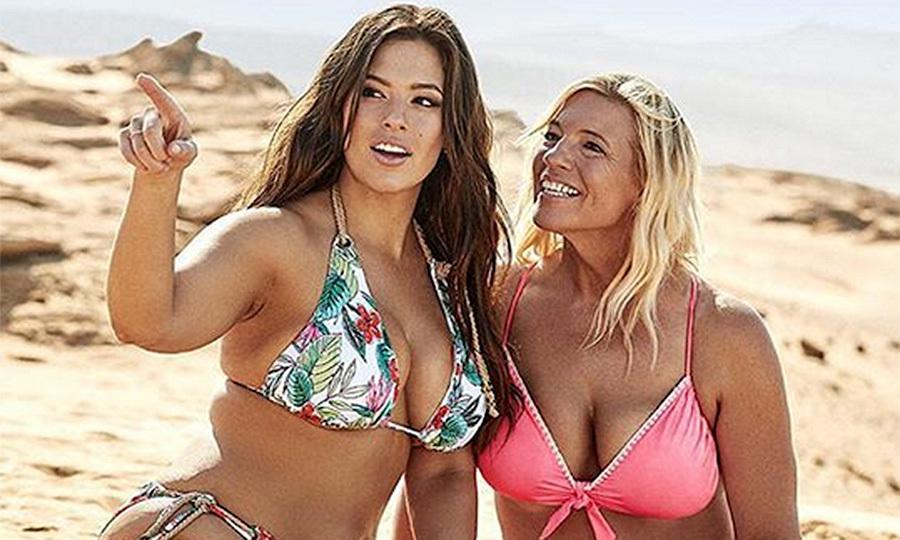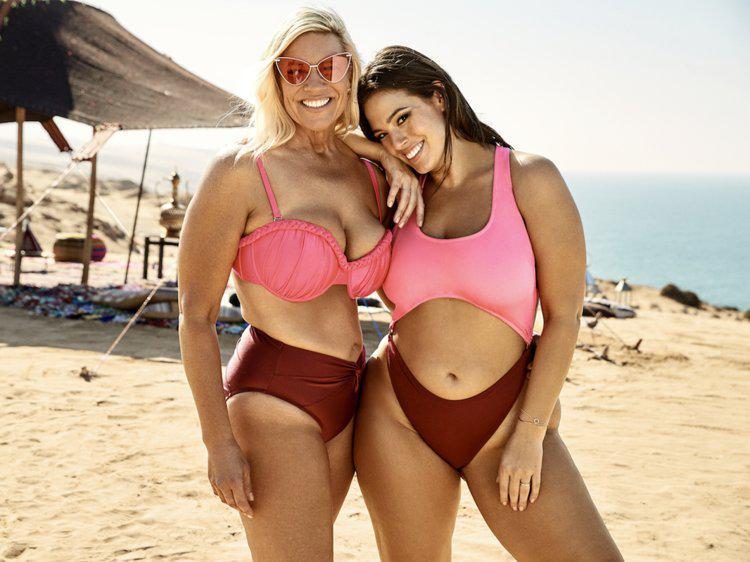The first image is the image on the left, the second image is the image on the right. Examine the images to the left and right. Is the description "One image shows two women side by side modelling bikinis with similar colors." accurate? Answer yes or no. Yes. The first image is the image on the left, the second image is the image on the right. Assess this claim about the two images: "The combined images show four females in bikinis on the beach, and three bikini tops are the same solid color.". Correct or not? Answer yes or no. Yes. 